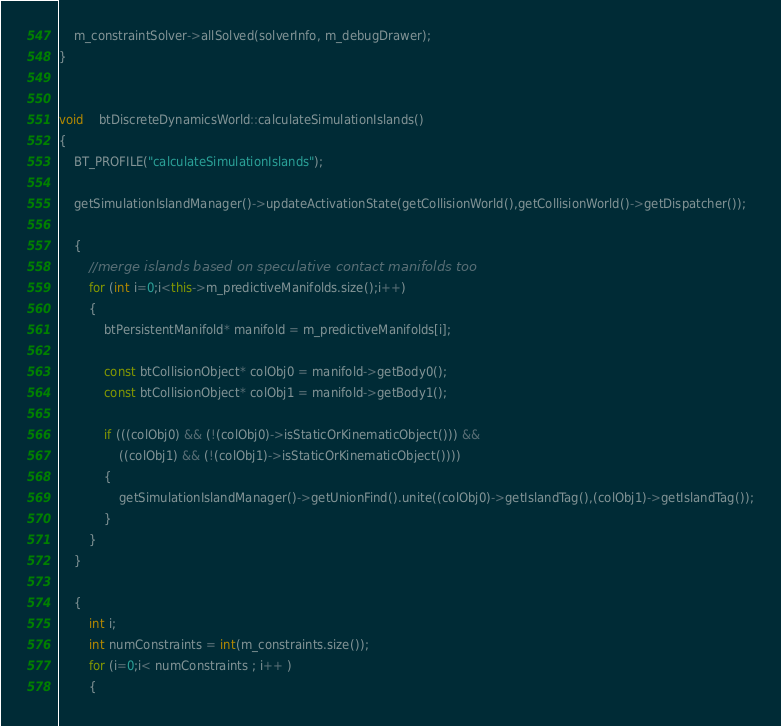<code> <loc_0><loc_0><loc_500><loc_500><_C++_>
	m_constraintSolver->allSolved(solverInfo, m_debugDrawer);
}


void	btDiscreteDynamicsWorld::calculateSimulationIslands()
{
	BT_PROFILE("calculateSimulationIslands");

	getSimulationIslandManager()->updateActivationState(getCollisionWorld(),getCollisionWorld()->getDispatcher());

    {
        //merge islands based on speculative contact manifolds too
        for (int i=0;i<this->m_predictiveManifolds.size();i++)
        {
            btPersistentManifold* manifold = m_predictiveManifolds[i];
            
            const btCollisionObject* colObj0 = manifold->getBody0();
            const btCollisionObject* colObj1 = manifold->getBody1();
            
            if (((colObj0) && (!(colObj0)->isStaticOrKinematicObject())) &&
                ((colObj1) && (!(colObj1)->isStaticOrKinematicObject())))
            {
				getSimulationIslandManager()->getUnionFind().unite((colObj0)->getIslandTag(),(colObj1)->getIslandTag());
            }
        }
    }
    
	{
		int i;
		int numConstraints = int(m_constraints.size());
		for (i=0;i< numConstraints ; i++ )
		{</code> 